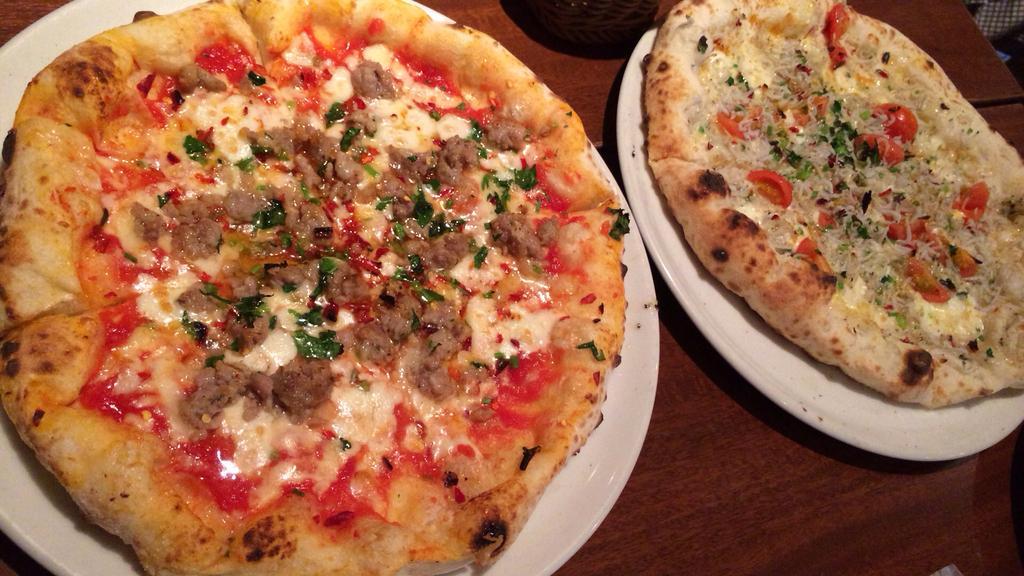Please provide a concise description of this image. In this image I see 2 white plates on which there are pizzas and I see that these 2 plates are on the brown color surface and I see a thing over here. 